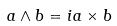Convert formula to latex. <formula><loc_0><loc_0><loc_500><loc_500>a \wedge b = i a \times b</formula> 